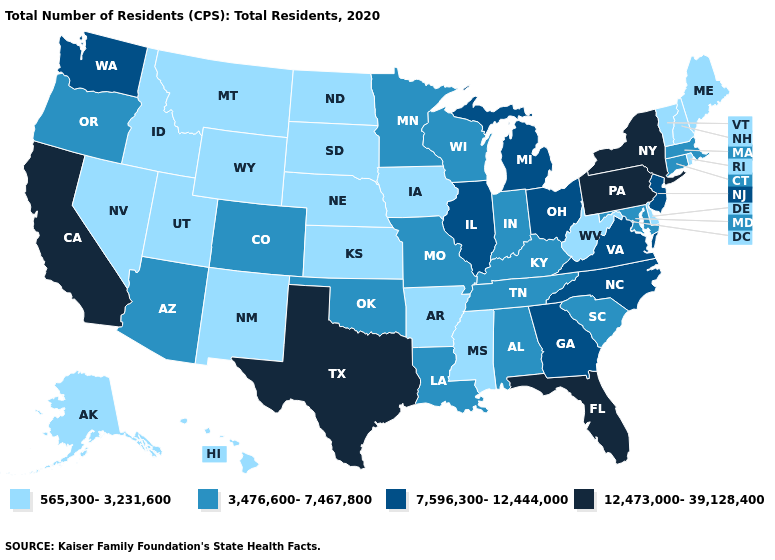Does South Carolina have a lower value than Louisiana?
Answer briefly. No. Does Washington have the lowest value in the USA?
Short answer required. No. Does Alaska have a higher value than Utah?
Give a very brief answer. No. Which states hav the highest value in the Northeast?
Write a very short answer. New York, Pennsylvania. Among the states that border Washington , which have the lowest value?
Be succinct. Idaho. What is the highest value in the South ?
Answer briefly. 12,473,000-39,128,400. What is the value of Indiana?
Answer briefly. 3,476,600-7,467,800. Is the legend a continuous bar?
Give a very brief answer. No. Which states have the lowest value in the Northeast?
Keep it brief. Maine, New Hampshire, Rhode Island, Vermont. What is the value of Arkansas?
Short answer required. 565,300-3,231,600. What is the lowest value in the Northeast?
Short answer required. 565,300-3,231,600. Which states have the highest value in the USA?
Concise answer only. California, Florida, New York, Pennsylvania, Texas. What is the value of Illinois?
Concise answer only. 7,596,300-12,444,000. Name the states that have a value in the range 12,473,000-39,128,400?
Give a very brief answer. California, Florida, New York, Pennsylvania, Texas. Does Arkansas have a lower value than Minnesota?
Be succinct. Yes. 